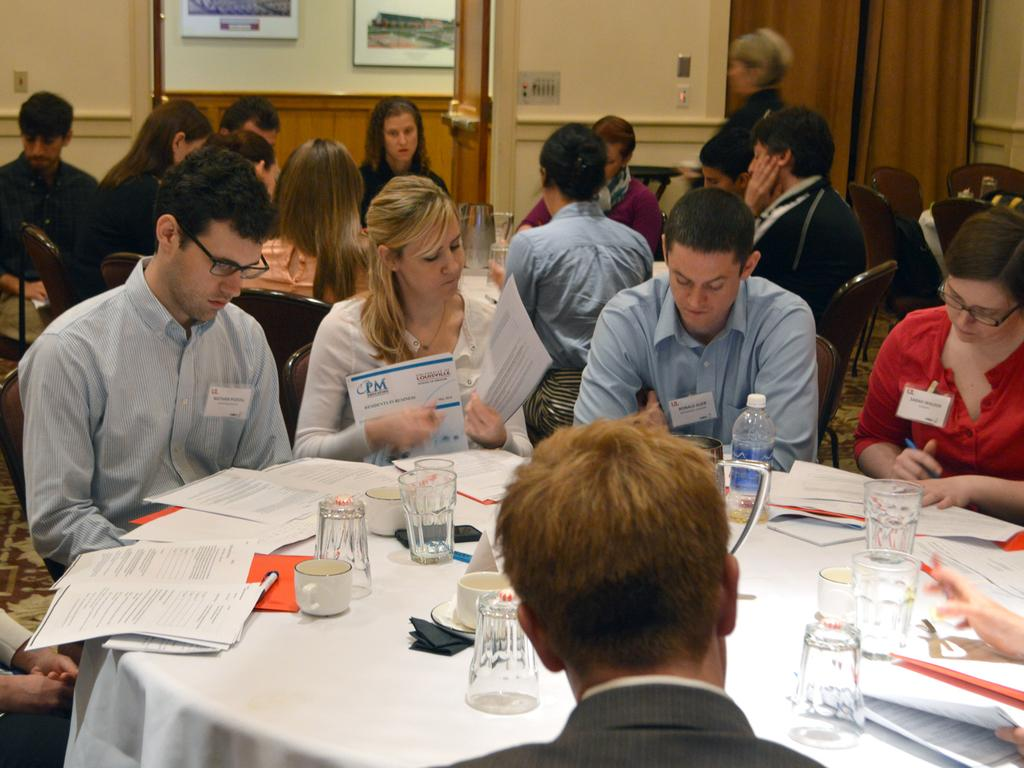What are the people in the image doing? The people in the image are sitting on chairs. What furniture is present in the image besides the chairs? There are tables in the image. What items can be seen on the tables? Glasses, a bottle, a cup, papers, and other objects are present on the tables. What can be seen in the background of the image? The background includes a wall, a board, and a curtain. What type of finger food is being served on the table in the image? There is no finger food present on the table in the image. What type of blade can be seen in the image? There is no blade present in the image. 